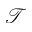<formula> <loc_0><loc_0><loc_500><loc_500>\mathcal { T }</formula> 